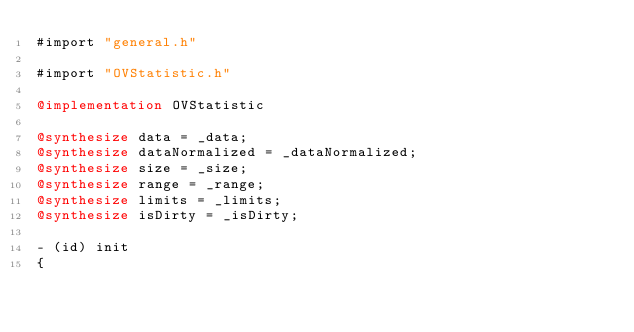<code> <loc_0><loc_0><loc_500><loc_500><_ObjectiveC_>#import "general.h"

#import "OVStatistic.h"

@implementation OVStatistic

@synthesize data = _data;
@synthesize dataNormalized = _dataNormalized;
@synthesize size = _size;
@synthesize range = _range;
@synthesize limits = _limits;
@synthesize isDirty = _isDirty;

- (id) init
{</code> 